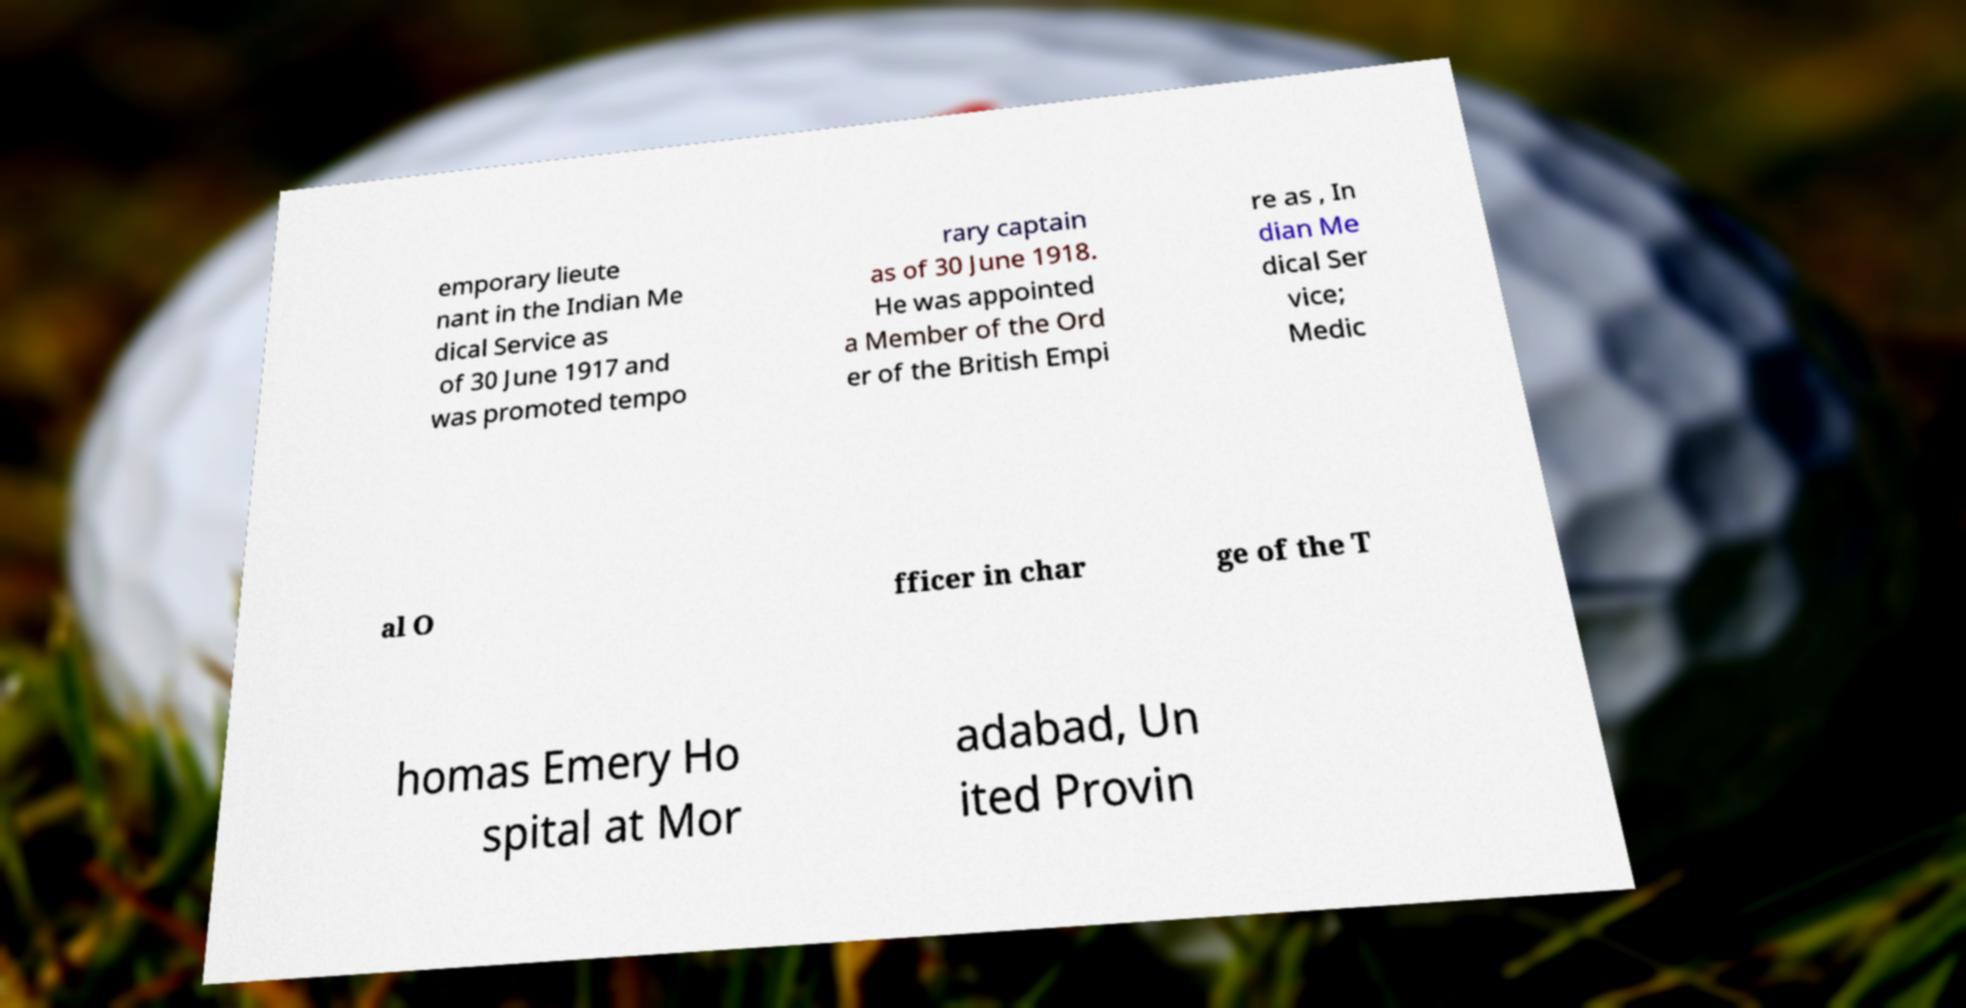I need the written content from this picture converted into text. Can you do that? emporary lieute nant in the Indian Me dical Service as of 30 June 1917 and was promoted tempo rary captain as of 30 June 1918. He was appointed a Member of the Ord er of the British Empi re as , In dian Me dical Ser vice; Medic al O fficer in char ge of the T homas Emery Ho spital at Mor adabad, Un ited Provin 